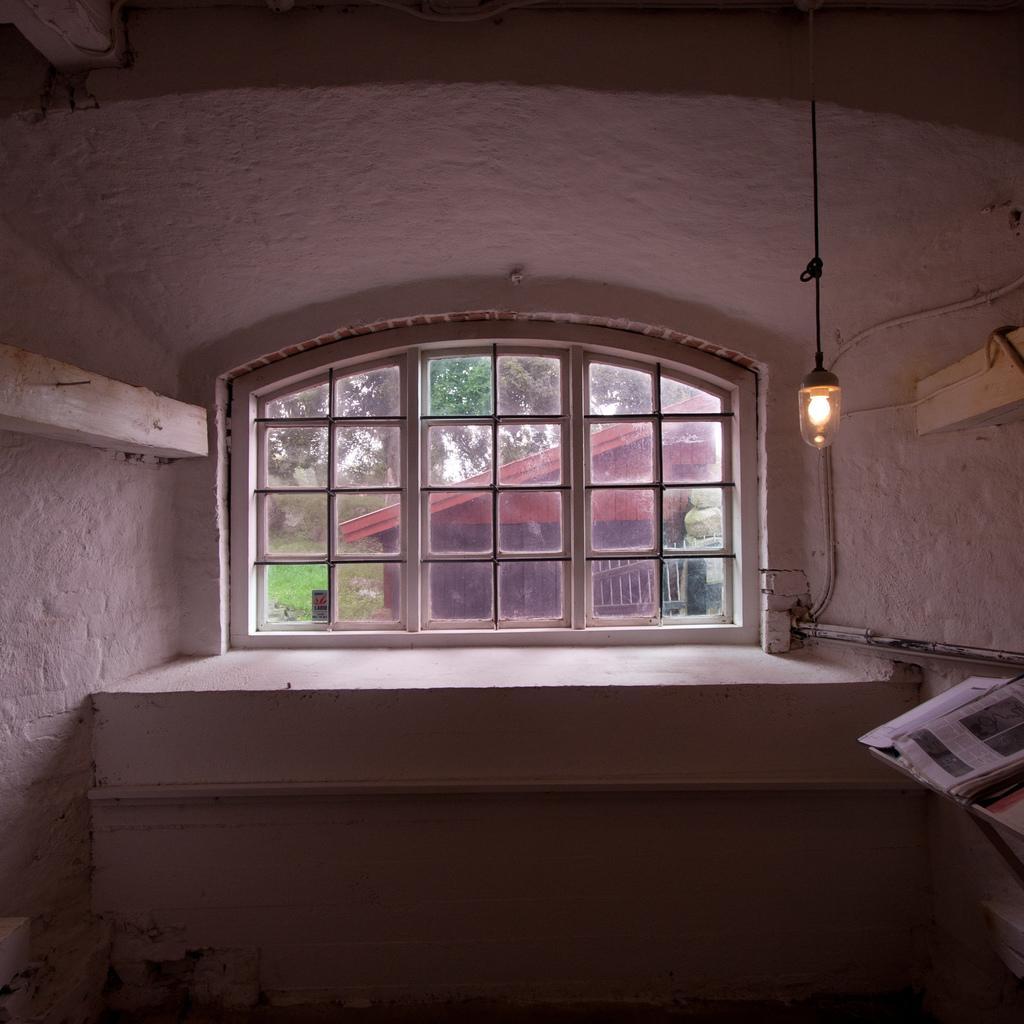In one or two sentences, can you explain what this image depicts? In this picture, we can see the inner view of a room, we can see walls, with some objects attached to it, we can see some objects in top left corner and bottom right side of the picture, and from the glass door we can see house, ground with grass, and tree, we can see the light with rope. 